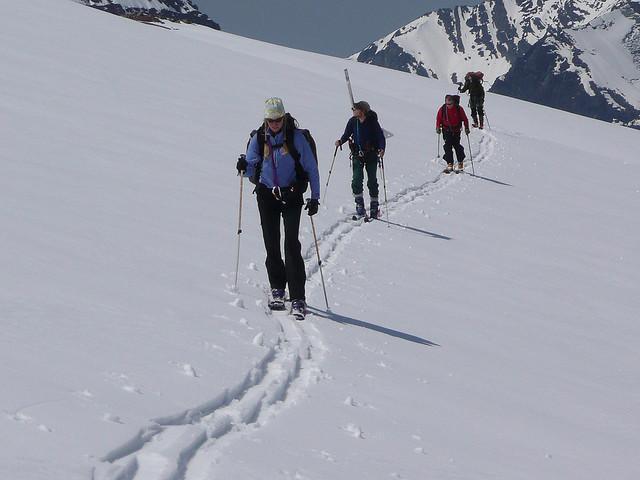How many people can be seen?
Give a very brief answer. 2. 